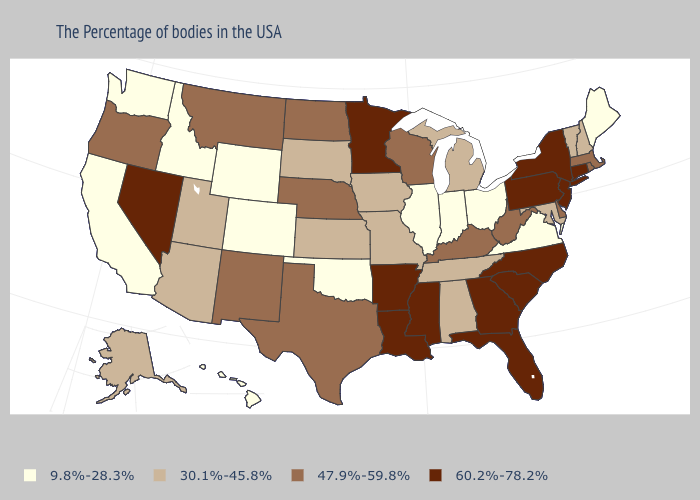Does Virginia have the highest value in the USA?
Write a very short answer. No. Which states have the lowest value in the USA?
Short answer required. Maine, Virginia, Ohio, Indiana, Illinois, Oklahoma, Wyoming, Colorado, Idaho, California, Washington, Hawaii. Does North Dakota have a lower value than South Carolina?
Short answer required. Yes. Among the states that border Maine , which have the highest value?
Answer briefly. New Hampshire. Which states have the highest value in the USA?
Give a very brief answer. Connecticut, New York, New Jersey, Pennsylvania, North Carolina, South Carolina, Florida, Georgia, Mississippi, Louisiana, Arkansas, Minnesota, Nevada. Does Mississippi have the same value as Oklahoma?
Concise answer only. No. Name the states that have a value in the range 60.2%-78.2%?
Quick response, please. Connecticut, New York, New Jersey, Pennsylvania, North Carolina, South Carolina, Florida, Georgia, Mississippi, Louisiana, Arkansas, Minnesota, Nevada. What is the value of Colorado?
Be succinct. 9.8%-28.3%. What is the lowest value in the MidWest?
Give a very brief answer. 9.8%-28.3%. What is the value of Florida?
Concise answer only. 60.2%-78.2%. What is the lowest value in the West?
Answer briefly. 9.8%-28.3%. Is the legend a continuous bar?
Quick response, please. No. Does Georgia have the same value as Maryland?
Short answer required. No. What is the value of Maryland?
Write a very short answer. 30.1%-45.8%. Name the states that have a value in the range 47.9%-59.8%?
Give a very brief answer. Massachusetts, Rhode Island, Delaware, West Virginia, Kentucky, Wisconsin, Nebraska, Texas, North Dakota, New Mexico, Montana, Oregon. 